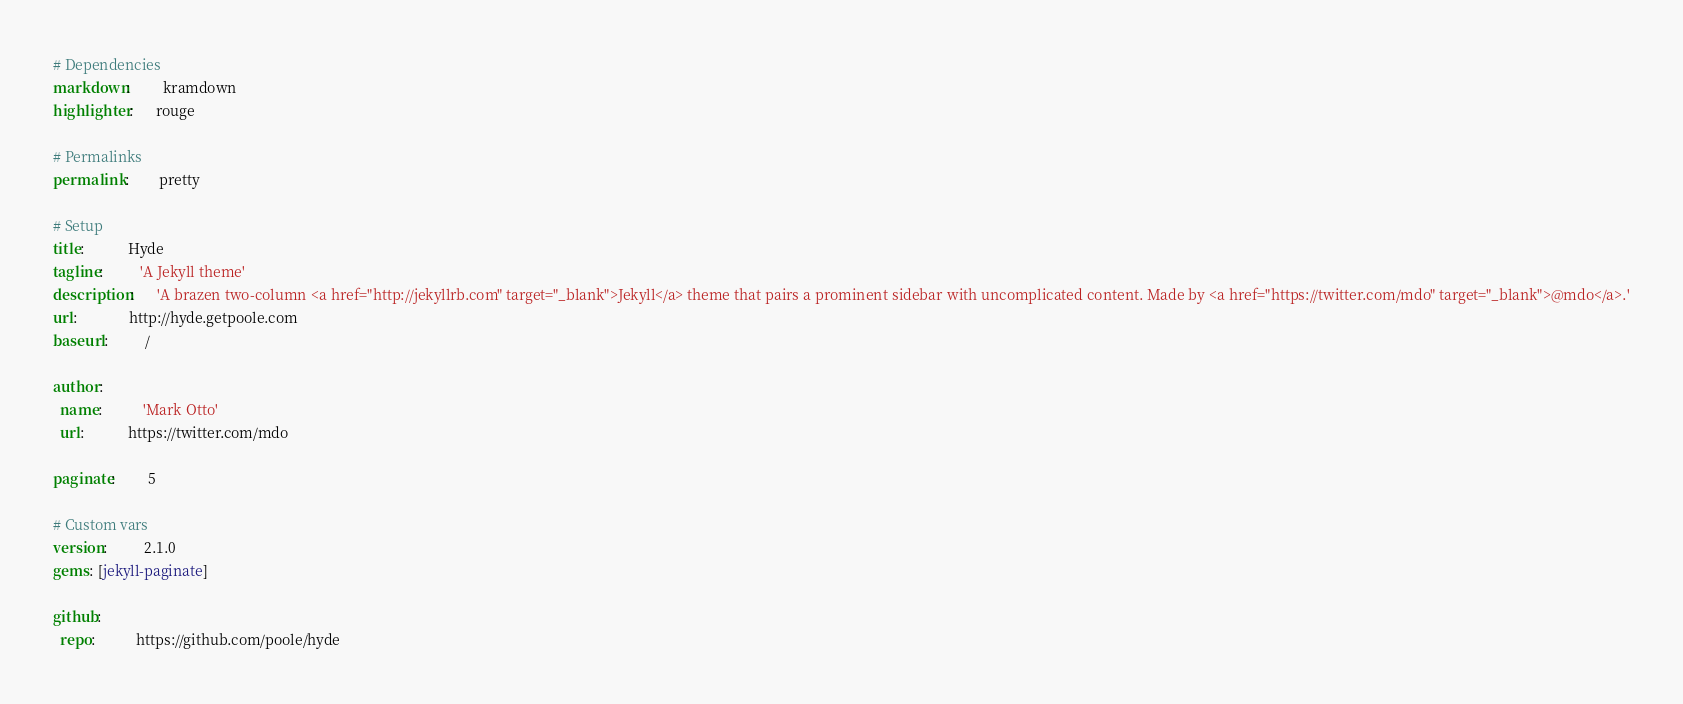<code> <loc_0><loc_0><loc_500><loc_500><_YAML_># Dependencies
markdown:         kramdown
highlighter:      rouge

# Permalinks
permalink:        pretty

# Setup
title:            Hyde
tagline:          'A Jekyll theme'
description:      'A brazen two-column <a href="http://jekyllrb.com" target="_blank">Jekyll</a> theme that pairs a prominent sidebar with uncomplicated content. Made by <a href="https://twitter.com/mdo" target="_blank">@mdo</a>.'
url:              http://hyde.getpoole.com
baseurl:          /

author:
  name:           'Mark Otto'
  url:            https://twitter.com/mdo

paginate:         5

# Custom vars
version:          2.1.0
gems: [jekyll-paginate]

github:
  repo:           https://github.com/poole/hyde
</code> 